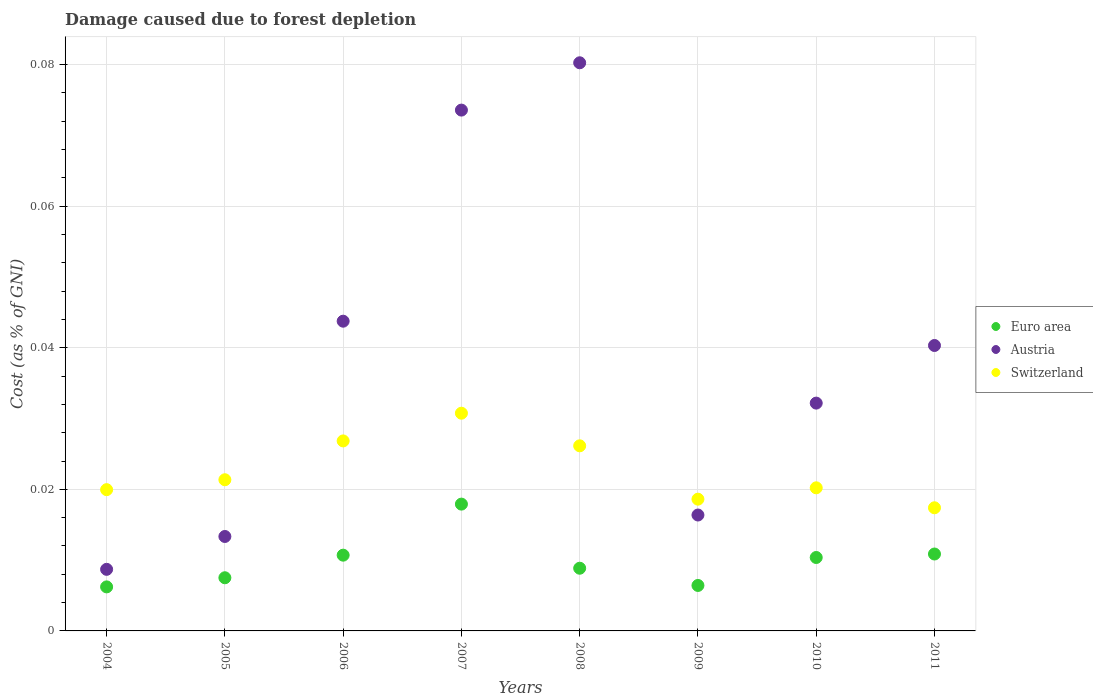Is the number of dotlines equal to the number of legend labels?
Provide a succinct answer. Yes. What is the cost of damage caused due to forest depletion in Austria in 2011?
Offer a terse response. 0.04. Across all years, what is the maximum cost of damage caused due to forest depletion in Austria?
Provide a succinct answer. 0.08. Across all years, what is the minimum cost of damage caused due to forest depletion in Austria?
Provide a short and direct response. 0.01. In which year was the cost of damage caused due to forest depletion in Switzerland minimum?
Give a very brief answer. 2011. What is the total cost of damage caused due to forest depletion in Euro area in the graph?
Your response must be concise. 0.08. What is the difference between the cost of damage caused due to forest depletion in Switzerland in 2006 and that in 2008?
Your answer should be compact. 0. What is the difference between the cost of damage caused due to forest depletion in Switzerland in 2009 and the cost of damage caused due to forest depletion in Austria in 2008?
Provide a short and direct response. -0.06. What is the average cost of damage caused due to forest depletion in Switzerland per year?
Provide a succinct answer. 0.02. In the year 2011, what is the difference between the cost of damage caused due to forest depletion in Switzerland and cost of damage caused due to forest depletion in Austria?
Give a very brief answer. -0.02. What is the ratio of the cost of damage caused due to forest depletion in Switzerland in 2009 to that in 2011?
Give a very brief answer. 1.07. Is the cost of damage caused due to forest depletion in Euro area in 2004 less than that in 2011?
Offer a terse response. Yes. Is the difference between the cost of damage caused due to forest depletion in Switzerland in 2005 and 2008 greater than the difference between the cost of damage caused due to forest depletion in Austria in 2005 and 2008?
Your response must be concise. Yes. What is the difference between the highest and the second highest cost of damage caused due to forest depletion in Switzerland?
Provide a short and direct response. 0. What is the difference between the highest and the lowest cost of damage caused due to forest depletion in Euro area?
Make the answer very short. 0.01. In how many years, is the cost of damage caused due to forest depletion in Euro area greater than the average cost of damage caused due to forest depletion in Euro area taken over all years?
Offer a very short reply. 4. Is the sum of the cost of damage caused due to forest depletion in Euro area in 2005 and 2009 greater than the maximum cost of damage caused due to forest depletion in Switzerland across all years?
Make the answer very short. No. Is it the case that in every year, the sum of the cost of damage caused due to forest depletion in Euro area and cost of damage caused due to forest depletion in Austria  is greater than the cost of damage caused due to forest depletion in Switzerland?
Give a very brief answer. No. Is the cost of damage caused due to forest depletion in Switzerland strictly greater than the cost of damage caused due to forest depletion in Austria over the years?
Make the answer very short. No. Is the cost of damage caused due to forest depletion in Switzerland strictly less than the cost of damage caused due to forest depletion in Austria over the years?
Make the answer very short. No. What is the difference between two consecutive major ticks on the Y-axis?
Provide a succinct answer. 0.02. Does the graph contain grids?
Make the answer very short. Yes. What is the title of the graph?
Your response must be concise. Damage caused due to forest depletion. Does "Peru" appear as one of the legend labels in the graph?
Offer a terse response. No. What is the label or title of the Y-axis?
Give a very brief answer. Cost (as % of GNI). What is the Cost (as % of GNI) in Euro area in 2004?
Offer a very short reply. 0.01. What is the Cost (as % of GNI) of Austria in 2004?
Provide a succinct answer. 0.01. What is the Cost (as % of GNI) of Switzerland in 2004?
Make the answer very short. 0.02. What is the Cost (as % of GNI) in Euro area in 2005?
Ensure brevity in your answer.  0.01. What is the Cost (as % of GNI) in Austria in 2005?
Offer a very short reply. 0.01. What is the Cost (as % of GNI) of Switzerland in 2005?
Provide a succinct answer. 0.02. What is the Cost (as % of GNI) in Euro area in 2006?
Offer a terse response. 0.01. What is the Cost (as % of GNI) of Austria in 2006?
Provide a short and direct response. 0.04. What is the Cost (as % of GNI) of Switzerland in 2006?
Offer a terse response. 0.03. What is the Cost (as % of GNI) of Euro area in 2007?
Ensure brevity in your answer.  0.02. What is the Cost (as % of GNI) of Austria in 2007?
Keep it short and to the point. 0.07. What is the Cost (as % of GNI) in Switzerland in 2007?
Offer a terse response. 0.03. What is the Cost (as % of GNI) of Euro area in 2008?
Provide a succinct answer. 0.01. What is the Cost (as % of GNI) of Austria in 2008?
Offer a very short reply. 0.08. What is the Cost (as % of GNI) of Switzerland in 2008?
Give a very brief answer. 0.03. What is the Cost (as % of GNI) in Euro area in 2009?
Provide a succinct answer. 0.01. What is the Cost (as % of GNI) in Austria in 2009?
Offer a terse response. 0.02. What is the Cost (as % of GNI) of Switzerland in 2009?
Make the answer very short. 0.02. What is the Cost (as % of GNI) of Euro area in 2010?
Make the answer very short. 0.01. What is the Cost (as % of GNI) in Austria in 2010?
Offer a terse response. 0.03. What is the Cost (as % of GNI) in Switzerland in 2010?
Make the answer very short. 0.02. What is the Cost (as % of GNI) of Euro area in 2011?
Make the answer very short. 0.01. What is the Cost (as % of GNI) of Austria in 2011?
Provide a succinct answer. 0.04. What is the Cost (as % of GNI) of Switzerland in 2011?
Ensure brevity in your answer.  0.02. Across all years, what is the maximum Cost (as % of GNI) of Euro area?
Keep it short and to the point. 0.02. Across all years, what is the maximum Cost (as % of GNI) in Austria?
Keep it short and to the point. 0.08. Across all years, what is the maximum Cost (as % of GNI) of Switzerland?
Offer a very short reply. 0.03. Across all years, what is the minimum Cost (as % of GNI) of Euro area?
Offer a terse response. 0.01. Across all years, what is the minimum Cost (as % of GNI) of Austria?
Give a very brief answer. 0.01. Across all years, what is the minimum Cost (as % of GNI) of Switzerland?
Make the answer very short. 0.02. What is the total Cost (as % of GNI) of Euro area in the graph?
Provide a succinct answer. 0.08. What is the total Cost (as % of GNI) of Austria in the graph?
Offer a terse response. 0.31. What is the total Cost (as % of GNI) of Switzerland in the graph?
Provide a short and direct response. 0.18. What is the difference between the Cost (as % of GNI) of Euro area in 2004 and that in 2005?
Give a very brief answer. -0. What is the difference between the Cost (as % of GNI) of Austria in 2004 and that in 2005?
Offer a terse response. -0. What is the difference between the Cost (as % of GNI) of Switzerland in 2004 and that in 2005?
Give a very brief answer. -0. What is the difference between the Cost (as % of GNI) of Euro area in 2004 and that in 2006?
Provide a short and direct response. -0. What is the difference between the Cost (as % of GNI) in Austria in 2004 and that in 2006?
Your response must be concise. -0.04. What is the difference between the Cost (as % of GNI) of Switzerland in 2004 and that in 2006?
Make the answer very short. -0.01. What is the difference between the Cost (as % of GNI) in Euro area in 2004 and that in 2007?
Offer a very short reply. -0.01. What is the difference between the Cost (as % of GNI) of Austria in 2004 and that in 2007?
Offer a very short reply. -0.06. What is the difference between the Cost (as % of GNI) of Switzerland in 2004 and that in 2007?
Give a very brief answer. -0.01. What is the difference between the Cost (as % of GNI) of Euro area in 2004 and that in 2008?
Provide a short and direct response. -0. What is the difference between the Cost (as % of GNI) in Austria in 2004 and that in 2008?
Keep it short and to the point. -0.07. What is the difference between the Cost (as % of GNI) of Switzerland in 2004 and that in 2008?
Offer a terse response. -0.01. What is the difference between the Cost (as % of GNI) of Euro area in 2004 and that in 2009?
Make the answer very short. -0. What is the difference between the Cost (as % of GNI) of Austria in 2004 and that in 2009?
Give a very brief answer. -0.01. What is the difference between the Cost (as % of GNI) in Switzerland in 2004 and that in 2009?
Ensure brevity in your answer.  0. What is the difference between the Cost (as % of GNI) of Euro area in 2004 and that in 2010?
Give a very brief answer. -0. What is the difference between the Cost (as % of GNI) of Austria in 2004 and that in 2010?
Provide a short and direct response. -0.02. What is the difference between the Cost (as % of GNI) in Switzerland in 2004 and that in 2010?
Offer a terse response. -0. What is the difference between the Cost (as % of GNI) in Euro area in 2004 and that in 2011?
Make the answer very short. -0. What is the difference between the Cost (as % of GNI) of Austria in 2004 and that in 2011?
Your response must be concise. -0.03. What is the difference between the Cost (as % of GNI) of Switzerland in 2004 and that in 2011?
Give a very brief answer. 0. What is the difference between the Cost (as % of GNI) in Euro area in 2005 and that in 2006?
Offer a terse response. -0. What is the difference between the Cost (as % of GNI) of Austria in 2005 and that in 2006?
Offer a very short reply. -0.03. What is the difference between the Cost (as % of GNI) in Switzerland in 2005 and that in 2006?
Provide a succinct answer. -0.01. What is the difference between the Cost (as % of GNI) of Euro area in 2005 and that in 2007?
Offer a terse response. -0.01. What is the difference between the Cost (as % of GNI) in Austria in 2005 and that in 2007?
Offer a very short reply. -0.06. What is the difference between the Cost (as % of GNI) of Switzerland in 2005 and that in 2007?
Offer a very short reply. -0.01. What is the difference between the Cost (as % of GNI) of Euro area in 2005 and that in 2008?
Your response must be concise. -0. What is the difference between the Cost (as % of GNI) of Austria in 2005 and that in 2008?
Your answer should be very brief. -0.07. What is the difference between the Cost (as % of GNI) in Switzerland in 2005 and that in 2008?
Ensure brevity in your answer.  -0. What is the difference between the Cost (as % of GNI) of Euro area in 2005 and that in 2009?
Offer a terse response. 0. What is the difference between the Cost (as % of GNI) in Austria in 2005 and that in 2009?
Keep it short and to the point. -0. What is the difference between the Cost (as % of GNI) of Switzerland in 2005 and that in 2009?
Make the answer very short. 0. What is the difference between the Cost (as % of GNI) of Euro area in 2005 and that in 2010?
Give a very brief answer. -0. What is the difference between the Cost (as % of GNI) of Austria in 2005 and that in 2010?
Make the answer very short. -0.02. What is the difference between the Cost (as % of GNI) of Switzerland in 2005 and that in 2010?
Your answer should be compact. 0. What is the difference between the Cost (as % of GNI) of Euro area in 2005 and that in 2011?
Provide a short and direct response. -0. What is the difference between the Cost (as % of GNI) of Austria in 2005 and that in 2011?
Your answer should be very brief. -0.03. What is the difference between the Cost (as % of GNI) of Switzerland in 2005 and that in 2011?
Offer a very short reply. 0. What is the difference between the Cost (as % of GNI) in Euro area in 2006 and that in 2007?
Offer a terse response. -0.01. What is the difference between the Cost (as % of GNI) in Austria in 2006 and that in 2007?
Your response must be concise. -0.03. What is the difference between the Cost (as % of GNI) of Switzerland in 2006 and that in 2007?
Your answer should be very brief. -0. What is the difference between the Cost (as % of GNI) of Euro area in 2006 and that in 2008?
Provide a short and direct response. 0. What is the difference between the Cost (as % of GNI) in Austria in 2006 and that in 2008?
Give a very brief answer. -0.04. What is the difference between the Cost (as % of GNI) of Switzerland in 2006 and that in 2008?
Offer a terse response. 0. What is the difference between the Cost (as % of GNI) of Euro area in 2006 and that in 2009?
Keep it short and to the point. 0. What is the difference between the Cost (as % of GNI) in Austria in 2006 and that in 2009?
Your response must be concise. 0.03. What is the difference between the Cost (as % of GNI) of Switzerland in 2006 and that in 2009?
Keep it short and to the point. 0.01. What is the difference between the Cost (as % of GNI) in Austria in 2006 and that in 2010?
Provide a short and direct response. 0.01. What is the difference between the Cost (as % of GNI) of Switzerland in 2006 and that in 2010?
Your response must be concise. 0.01. What is the difference between the Cost (as % of GNI) in Euro area in 2006 and that in 2011?
Give a very brief answer. -0. What is the difference between the Cost (as % of GNI) of Austria in 2006 and that in 2011?
Your answer should be very brief. 0. What is the difference between the Cost (as % of GNI) in Switzerland in 2006 and that in 2011?
Provide a succinct answer. 0.01. What is the difference between the Cost (as % of GNI) in Euro area in 2007 and that in 2008?
Give a very brief answer. 0.01. What is the difference between the Cost (as % of GNI) of Austria in 2007 and that in 2008?
Your response must be concise. -0.01. What is the difference between the Cost (as % of GNI) of Switzerland in 2007 and that in 2008?
Offer a very short reply. 0. What is the difference between the Cost (as % of GNI) of Euro area in 2007 and that in 2009?
Keep it short and to the point. 0.01. What is the difference between the Cost (as % of GNI) in Austria in 2007 and that in 2009?
Make the answer very short. 0.06. What is the difference between the Cost (as % of GNI) in Switzerland in 2007 and that in 2009?
Make the answer very short. 0.01. What is the difference between the Cost (as % of GNI) in Euro area in 2007 and that in 2010?
Give a very brief answer. 0.01. What is the difference between the Cost (as % of GNI) in Austria in 2007 and that in 2010?
Your response must be concise. 0.04. What is the difference between the Cost (as % of GNI) in Switzerland in 2007 and that in 2010?
Your response must be concise. 0.01. What is the difference between the Cost (as % of GNI) of Euro area in 2007 and that in 2011?
Your answer should be very brief. 0.01. What is the difference between the Cost (as % of GNI) of Switzerland in 2007 and that in 2011?
Provide a succinct answer. 0.01. What is the difference between the Cost (as % of GNI) in Euro area in 2008 and that in 2009?
Your answer should be very brief. 0. What is the difference between the Cost (as % of GNI) in Austria in 2008 and that in 2009?
Ensure brevity in your answer.  0.06. What is the difference between the Cost (as % of GNI) of Switzerland in 2008 and that in 2009?
Provide a succinct answer. 0.01. What is the difference between the Cost (as % of GNI) in Euro area in 2008 and that in 2010?
Your response must be concise. -0. What is the difference between the Cost (as % of GNI) in Austria in 2008 and that in 2010?
Your answer should be very brief. 0.05. What is the difference between the Cost (as % of GNI) of Switzerland in 2008 and that in 2010?
Ensure brevity in your answer.  0.01. What is the difference between the Cost (as % of GNI) of Euro area in 2008 and that in 2011?
Provide a short and direct response. -0. What is the difference between the Cost (as % of GNI) in Austria in 2008 and that in 2011?
Offer a terse response. 0.04. What is the difference between the Cost (as % of GNI) of Switzerland in 2008 and that in 2011?
Provide a succinct answer. 0.01. What is the difference between the Cost (as % of GNI) of Euro area in 2009 and that in 2010?
Offer a very short reply. -0. What is the difference between the Cost (as % of GNI) in Austria in 2009 and that in 2010?
Provide a succinct answer. -0.02. What is the difference between the Cost (as % of GNI) of Switzerland in 2009 and that in 2010?
Your answer should be very brief. -0. What is the difference between the Cost (as % of GNI) in Euro area in 2009 and that in 2011?
Make the answer very short. -0. What is the difference between the Cost (as % of GNI) of Austria in 2009 and that in 2011?
Make the answer very short. -0.02. What is the difference between the Cost (as % of GNI) in Switzerland in 2009 and that in 2011?
Your answer should be very brief. 0. What is the difference between the Cost (as % of GNI) in Euro area in 2010 and that in 2011?
Offer a terse response. -0. What is the difference between the Cost (as % of GNI) of Austria in 2010 and that in 2011?
Make the answer very short. -0.01. What is the difference between the Cost (as % of GNI) of Switzerland in 2010 and that in 2011?
Keep it short and to the point. 0. What is the difference between the Cost (as % of GNI) in Euro area in 2004 and the Cost (as % of GNI) in Austria in 2005?
Make the answer very short. -0.01. What is the difference between the Cost (as % of GNI) of Euro area in 2004 and the Cost (as % of GNI) of Switzerland in 2005?
Make the answer very short. -0.02. What is the difference between the Cost (as % of GNI) in Austria in 2004 and the Cost (as % of GNI) in Switzerland in 2005?
Make the answer very short. -0.01. What is the difference between the Cost (as % of GNI) of Euro area in 2004 and the Cost (as % of GNI) of Austria in 2006?
Offer a very short reply. -0.04. What is the difference between the Cost (as % of GNI) of Euro area in 2004 and the Cost (as % of GNI) of Switzerland in 2006?
Offer a terse response. -0.02. What is the difference between the Cost (as % of GNI) in Austria in 2004 and the Cost (as % of GNI) in Switzerland in 2006?
Give a very brief answer. -0.02. What is the difference between the Cost (as % of GNI) of Euro area in 2004 and the Cost (as % of GNI) of Austria in 2007?
Provide a short and direct response. -0.07. What is the difference between the Cost (as % of GNI) in Euro area in 2004 and the Cost (as % of GNI) in Switzerland in 2007?
Ensure brevity in your answer.  -0.02. What is the difference between the Cost (as % of GNI) in Austria in 2004 and the Cost (as % of GNI) in Switzerland in 2007?
Offer a very short reply. -0.02. What is the difference between the Cost (as % of GNI) of Euro area in 2004 and the Cost (as % of GNI) of Austria in 2008?
Your answer should be very brief. -0.07. What is the difference between the Cost (as % of GNI) in Euro area in 2004 and the Cost (as % of GNI) in Switzerland in 2008?
Offer a very short reply. -0.02. What is the difference between the Cost (as % of GNI) in Austria in 2004 and the Cost (as % of GNI) in Switzerland in 2008?
Your answer should be compact. -0.02. What is the difference between the Cost (as % of GNI) in Euro area in 2004 and the Cost (as % of GNI) in Austria in 2009?
Offer a terse response. -0.01. What is the difference between the Cost (as % of GNI) of Euro area in 2004 and the Cost (as % of GNI) of Switzerland in 2009?
Offer a terse response. -0.01. What is the difference between the Cost (as % of GNI) of Austria in 2004 and the Cost (as % of GNI) of Switzerland in 2009?
Offer a very short reply. -0.01. What is the difference between the Cost (as % of GNI) in Euro area in 2004 and the Cost (as % of GNI) in Austria in 2010?
Your response must be concise. -0.03. What is the difference between the Cost (as % of GNI) of Euro area in 2004 and the Cost (as % of GNI) of Switzerland in 2010?
Offer a very short reply. -0.01. What is the difference between the Cost (as % of GNI) of Austria in 2004 and the Cost (as % of GNI) of Switzerland in 2010?
Provide a short and direct response. -0.01. What is the difference between the Cost (as % of GNI) of Euro area in 2004 and the Cost (as % of GNI) of Austria in 2011?
Keep it short and to the point. -0.03. What is the difference between the Cost (as % of GNI) of Euro area in 2004 and the Cost (as % of GNI) of Switzerland in 2011?
Your response must be concise. -0.01. What is the difference between the Cost (as % of GNI) of Austria in 2004 and the Cost (as % of GNI) of Switzerland in 2011?
Your answer should be compact. -0.01. What is the difference between the Cost (as % of GNI) in Euro area in 2005 and the Cost (as % of GNI) in Austria in 2006?
Your response must be concise. -0.04. What is the difference between the Cost (as % of GNI) in Euro area in 2005 and the Cost (as % of GNI) in Switzerland in 2006?
Your answer should be compact. -0.02. What is the difference between the Cost (as % of GNI) in Austria in 2005 and the Cost (as % of GNI) in Switzerland in 2006?
Your answer should be very brief. -0.01. What is the difference between the Cost (as % of GNI) in Euro area in 2005 and the Cost (as % of GNI) in Austria in 2007?
Your answer should be very brief. -0.07. What is the difference between the Cost (as % of GNI) in Euro area in 2005 and the Cost (as % of GNI) in Switzerland in 2007?
Offer a terse response. -0.02. What is the difference between the Cost (as % of GNI) of Austria in 2005 and the Cost (as % of GNI) of Switzerland in 2007?
Make the answer very short. -0.02. What is the difference between the Cost (as % of GNI) of Euro area in 2005 and the Cost (as % of GNI) of Austria in 2008?
Offer a terse response. -0.07. What is the difference between the Cost (as % of GNI) in Euro area in 2005 and the Cost (as % of GNI) in Switzerland in 2008?
Ensure brevity in your answer.  -0.02. What is the difference between the Cost (as % of GNI) of Austria in 2005 and the Cost (as % of GNI) of Switzerland in 2008?
Provide a succinct answer. -0.01. What is the difference between the Cost (as % of GNI) in Euro area in 2005 and the Cost (as % of GNI) in Austria in 2009?
Provide a short and direct response. -0.01. What is the difference between the Cost (as % of GNI) in Euro area in 2005 and the Cost (as % of GNI) in Switzerland in 2009?
Give a very brief answer. -0.01. What is the difference between the Cost (as % of GNI) in Austria in 2005 and the Cost (as % of GNI) in Switzerland in 2009?
Offer a terse response. -0.01. What is the difference between the Cost (as % of GNI) of Euro area in 2005 and the Cost (as % of GNI) of Austria in 2010?
Give a very brief answer. -0.02. What is the difference between the Cost (as % of GNI) of Euro area in 2005 and the Cost (as % of GNI) of Switzerland in 2010?
Your answer should be compact. -0.01. What is the difference between the Cost (as % of GNI) in Austria in 2005 and the Cost (as % of GNI) in Switzerland in 2010?
Your response must be concise. -0.01. What is the difference between the Cost (as % of GNI) of Euro area in 2005 and the Cost (as % of GNI) of Austria in 2011?
Your answer should be compact. -0.03. What is the difference between the Cost (as % of GNI) of Euro area in 2005 and the Cost (as % of GNI) of Switzerland in 2011?
Provide a short and direct response. -0.01. What is the difference between the Cost (as % of GNI) in Austria in 2005 and the Cost (as % of GNI) in Switzerland in 2011?
Make the answer very short. -0. What is the difference between the Cost (as % of GNI) in Euro area in 2006 and the Cost (as % of GNI) in Austria in 2007?
Your answer should be compact. -0.06. What is the difference between the Cost (as % of GNI) of Euro area in 2006 and the Cost (as % of GNI) of Switzerland in 2007?
Ensure brevity in your answer.  -0.02. What is the difference between the Cost (as % of GNI) of Austria in 2006 and the Cost (as % of GNI) of Switzerland in 2007?
Your answer should be compact. 0.01. What is the difference between the Cost (as % of GNI) in Euro area in 2006 and the Cost (as % of GNI) in Austria in 2008?
Give a very brief answer. -0.07. What is the difference between the Cost (as % of GNI) in Euro area in 2006 and the Cost (as % of GNI) in Switzerland in 2008?
Offer a terse response. -0.02. What is the difference between the Cost (as % of GNI) in Austria in 2006 and the Cost (as % of GNI) in Switzerland in 2008?
Give a very brief answer. 0.02. What is the difference between the Cost (as % of GNI) in Euro area in 2006 and the Cost (as % of GNI) in Austria in 2009?
Keep it short and to the point. -0.01. What is the difference between the Cost (as % of GNI) of Euro area in 2006 and the Cost (as % of GNI) of Switzerland in 2009?
Your answer should be compact. -0.01. What is the difference between the Cost (as % of GNI) in Austria in 2006 and the Cost (as % of GNI) in Switzerland in 2009?
Provide a short and direct response. 0.03. What is the difference between the Cost (as % of GNI) of Euro area in 2006 and the Cost (as % of GNI) of Austria in 2010?
Offer a very short reply. -0.02. What is the difference between the Cost (as % of GNI) in Euro area in 2006 and the Cost (as % of GNI) in Switzerland in 2010?
Provide a short and direct response. -0.01. What is the difference between the Cost (as % of GNI) of Austria in 2006 and the Cost (as % of GNI) of Switzerland in 2010?
Your answer should be very brief. 0.02. What is the difference between the Cost (as % of GNI) of Euro area in 2006 and the Cost (as % of GNI) of Austria in 2011?
Offer a terse response. -0.03. What is the difference between the Cost (as % of GNI) of Euro area in 2006 and the Cost (as % of GNI) of Switzerland in 2011?
Give a very brief answer. -0.01. What is the difference between the Cost (as % of GNI) in Austria in 2006 and the Cost (as % of GNI) in Switzerland in 2011?
Offer a very short reply. 0.03. What is the difference between the Cost (as % of GNI) of Euro area in 2007 and the Cost (as % of GNI) of Austria in 2008?
Your answer should be very brief. -0.06. What is the difference between the Cost (as % of GNI) of Euro area in 2007 and the Cost (as % of GNI) of Switzerland in 2008?
Offer a terse response. -0.01. What is the difference between the Cost (as % of GNI) in Austria in 2007 and the Cost (as % of GNI) in Switzerland in 2008?
Make the answer very short. 0.05. What is the difference between the Cost (as % of GNI) of Euro area in 2007 and the Cost (as % of GNI) of Austria in 2009?
Offer a terse response. 0. What is the difference between the Cost (as % of GNI) of Euro area in 2007 and the Cost (as % of GNI) of Switzerland in 2009?
Your answer should be very brief. -0. What is the difference between the Cost (as % of GNI) in Austria in 2007 and the Cost (as % of GNI) in Switzerland in 2009?
Offer a terse response. 0.06. What is the difference between the Cost (as % of GNI) of Euro area in 2007 and the Cost (as % of GNI) of Austria in 2010?
Make the answer very short. -0.01. What is the difference between the Cost (as % of GNI) of Euro area in 2007 and the Cost (as % of GNI) of Switzerland in 2010?
Your answer should be very brief. -0. What is the difference between the Cost (as % of GNI) of Austria in 2007 and the Cost (as % of GNI) of Switzerland in 2010?
Provide a short and direct response. 0.05. What is the difference between the Cost (as % of GNI) of Euro area in 2007 and the Cost (as % of GNI) of Austria in 2011?
Ensure brevity in your answer.  -0.02. What is the difference between the Cost (as % of GNI) of Euro area in 2007 and the Cost (as % of GNI) of Switzerland in 2011?
Offer a terse response. 0. What is the difference between the Cost (as % of GNI) of Austria in 2007 and the Cost (as % of GNI) of Switzerland in 2011?
Make the answer very short. 0.06. What is the difference between the Cost (as % of GNI) in Euro area in 2008 and the Cost (as % of GNI) in Austria in 2009?
Offer a very short reply. -0.01. What is the difference between the Cost (as % of GNI) of Euro area in 2008 and the Cost (as % of GNI) of Switzerland in 2009?
Make the answer very short. -0.01. What is the difference between the Cost (as % of GNI) in Austria in 2008 and the Cost (as % of GNI) in Switzerland in 2009?
Your answer should be compact. 0.06. What is the difference between the Cost (as % of GNI) of Euro area in 2008 and the Cost (as % of GNI) of Austria in 2010?
Your answer should be very brief. -0.02. What is the difference between the Cost (as % of GNI) of Euro area in 2008 and the Cost (as % of GNI) of Switzerland in 2010?
Make the answer very short. -0.01. What is the difference between the Cost (as % of GNI) of Austria in 2008 and the Cost (as % of GNI) of Switzerland in 2010?
Offer a very short reply. 0.06. What is the difference between the Cost (as % of GNI) of Euro area in 2008 and the Cost (as % of GNI) of Austria in 2011?
Provide a short and direct response. -0.03. What is the difference between the Cost (as % of GNI) of Euro area in 2008 and the Cost (as % of GNI) of Switzerland in 2011?
Provide a succinct answer. -0.01. What is the difference between the Cost (as % of GNI) in Austria in 2008 and the Cost (as % of GNI) in Switzerland in 2011?
Ensure brevity in your answer.  0.06. What is the difference between the Cost (as % of GNI) in Euro area in 2009 and the Cost (as % of GNI) in Austria in 2010?
Give a very brief answer. -0.03. What is the difference between the Cost (as % of GNI) of Euro area in 2009 and the Cost (as % of GNI) of Switzerland in 2010?
Your answer should be very brief. -0.01. What is the difference between the Cost (as % of GNI) of Austria in 2009 and the Cost (as % of GNI) of Switzerland in 2010?
Offer a very short reply. -0. What is the difference between the Cost (as % of GNI) of Euro area in 2009 and the Cost (as % of GNI) of Austria in 2011?
Make the answer very short. -0.03. What is the difference between the Cost (as % of GNI) in Euro area in 2009 and the Cost (as % of GNI) in Switzerland in 2011?
Provide a succinct answer. -0.01. What is the difference between the Cost (as % of GNI) in Austria in 2009 and the Cost (as % of GNI) in Switzerland in 2011?
Make the answer very short. -0. What is the difference between the Cost (as % of GNI) in Euro area in 2010 and the Cost (as % of GNI) in Austria in 2011?
Provide a short and direct response. -0.03. What is the difference between the Cost (as % of GNI) in Euro area in 2010 and the Cost (as % of GNI) in Switzerland in 2011?
Ensure brevity in your answer.  -0.01. What is the difference between the Cost (as % of GNI) in Austria in 2010 and the Cost (as % of GNI) in Switzerland in 2011?
Offer a terse response. 0.01. What is the average Cost (as % of GNI) in Euro area per year?
Your answer should be compact. 0.01. What is the average Cost (as % of GNI) of Austria per year?
Give a very brief answer. 0.04. What is the average Cost (as % of GNI) of Switzerland per year?
Your response must be concise. 0.02. In the year 2004, what is the difference between the Cost (as % of GNI) in Euro area and Cost (as % of GNI) in Austria?
Give a very brief answer. -0. In the year 2004, what is the difference between the Cost (as % of GNI) in Euro area and Cost (as % of GNI) in Switzerland?
Your response must be concise. -0.01. In the year 2004, what is the difference between the Cost (as % of GNI) of Austria and Cost (as % of GNI) of Switzerland?
Offer a terse response. -0.01. In the year 2005, what is the difference between the Cost (as % of GNI) of Euro area and Cost (as % of GNI) of Austria?
Give a very brief answer. -0.01. In the year 2005, what is the difference between the Cost (as % of GNI) of Euro area and Cost (as % of GNI) of Switzerland?
Your answer should be compact. -0.01. In the year 2005, what is the difference between the Cost (as % of GNI) in Austria and Cost (as % of GNI) in Switzerland?
Offer a very short reply. -0.01. In the year 2006, what is the difference between the Cost (as % of GNI) in Euro area and Cost (as % of GNI) in Austria?
Offer a terse response. -0.03. In the year 2006, what is the difference between the Cost (as % of GNI) of Euro area and Cost (as % of GNI) of Switzerland?
Make the answer very short. -0.02. In the year 2006, what is the difference between the Cost (as % of GNI) in Austria and Cost (as % of GNI) in Switzerland?
Your answer should be compact. 0.02. In the year 2007, what is the difference between the Cost (as % of GNI) in Euro area and Cost (as % of GNI) in Austria?
Make the answer very short. -0.06. In the year 2007, what is the difference between the Cost (as % of GNI) of Euro area and Cost (as % of GNI) of Switzerland?
Offer a terse response. -0.01. In the year 2007, what is the difference between the Cost (as % of GNI) in Austria and Cost (as % of GNI) in Switzerland?
Your response must be concise. 0.04. In the year 2008, what is the difference between the Cost (as % of GNI) of Euro area and Cost (as % of GNI) of Austria?
Your answer should be very brief. -0.07. In the year 2008, what is the difference between the Cost (as % of GNI) in Euro area and Cost (as % of GNI) in Switzerland?
Your response must be concise. -0.02. In the year 2008, what is the difference between the Cost (as % of GNI) of Austria and Cost (as % of GNI) of Switzerland?
Your answer should be very brief. 0.05. In the year 2009, what is the difference between the Cost (as % of GNI) in Euro area and Cost (as % of GNI) in Austria?
Make the answer very short. -0.01. In the year 2009, what is the difference between the Cost (as % of GNI) of Euro area and Cost (as % of GNI) of Switzerland?
Keep it short and to the point. -0.01. In the year 2009, what is the difference between the Cost (as % of GNI) of Austria and Cost (as % of GNI) of Switzerland?
Give a very brief answer. -0. In the year 2010, what is the difference between the Cost (as % of GNI) in Euro area and Cost (as % of GNI) in Austria?
Offer a terse response. -0.02. In the year 2010, what is the difference between the Cost (as % of GNI) in Euro area and Cost (as % of GNI) in Switzerland?
Offer a very short reply. -0.01. In the year 2010, what is the difference between the Cost (as % of GNI) of Austria and Cost (as % of GNI) of Switzerland?
Your answer should be very brief. 0.01. In the year 2011, what is the difference between the Cost (as % of GNI) of Euro area and Cost (as % of GNI) of Austria?
Give a very brief answer. -0.03. In the year 2011, what is the difference between the Cost (as % of GNI) in Euro area and Cost (as % of GNI) in Switzerland?
Your response must be concise. -0.01. In the year 2011, what is the difference between the Cost (as % of GNI) of Austria and Cost (as % of GNI) of Switzerland?
Offer a very short reply. 0.02. What is the ratio of the Cost (as % of GNI) of Euro area in 2004 to that in 2005?
Provide a short and direct response. 0.83. What is the ratio of the Cost (as % of GNI) of Austria in 2004 to that in 2005?
Offer a very short reply. 0.65. What is the ratio of the Cost (as % of GNI) in Switzerland in 2004 to that in 2005?
Ensure brevity in your answer.  0.93. What is the ratio of the Cost (as % of GNI) in Euro area in 2004 to that in 2006?
Offer a very short reply. 0.58. What is the ratio of the Cost (as % of GNI) in Austria in 2004 to that in 2006?
Give a very brief answer. 0.2. What is the ratio of the Cost (as % of GNI) in Switzerland in 2004 to that in 2006?
Your answer should be compact. 0.74. What is the ratio of the Cost (as % of GNI) in Euro area in 2004 to that in 2007?
Provide a succinct answer. 0.35. What is the ratio of the Cost (as % of GNI) of Austria in 2004 to that in 2007?
Your answer should be very brief. 0.12. What is the ratio of the Cost (as % of GNI) in Switzerland in 2004 to that in 2007?
Your answer should be very brief. 0.65. What is the ratio of the Cost (as % of GNI) in Euro area in 2004 to that in 2008?
Your response must be concise. 0.7. What is the ratio of the Cost (as % of GNI) of Austria in 2004 to that in 2008?
Give a very brief answer. 0.11. What is the ratio of the Cost (as % of GNI) in Switzerland in 2004 to that in 2008?
Offer a very short reply. 0.76. What is the ratio of the Cost (as % of GNI) in Euro area in 2004 to that in 2009?
Provide a succinct answer. 0.97. What is the ratio of the Cost (as % of GNI) of Austria in 2004 to that in 2009?
Offer a terse response. 0.53. What is the ratio of the Cost (as % of GNI) of Switzerland in 2004 to that in 2009?
Your answer should be compact. 1.07. What is the ratio of the Cost (as % of GNI) of Euro area in 2004 to that in 2010?
Your answer should be compact. 0.6. What is the ratio of the Cost (as % of GNI) in Austria in 2004 to that in 2010?
Your answer should be very brief. 0.27. What is the ratio of the Cost (as % of GNI) of Switzerland in 2004 to that in 2010?
Provide a succinct answer. 0.99. What is the ratio of the Cost (as % of GNI) of Euro area in 2004 to that in 2011?
Give a very brief answer. 0.57. What is the ratio of the Cost (as % of GNI) in Austria in 2004 to that in 2011?
Your answer should be very brief. 0.22. What is the ratio of the Cost (as % of GNI) of Switzerland in 2004 to that in 2011?
Provide a succinct answer. 1.15. What is the ratio of the Cost (as % of GNI) in Euro area in 2005 to that in 2006?
Your response must be concise. 0.7. What is the ratio of the Cost (as % of GNI) in Austria in 2005 to that in 2006?
Make the answer very short. 0.3. What is the ratio of the Cost (as % of GNI) in Switzerland in 2005 to that in 2006?
Provide a short and direct response. 0.8. What is the ratio of the Cost (as % of GNI) in Euro area in 2005 to that in 2007?
Your answer should be very brief. 0.42. What is the ratio of the Cost (as % of GNI) in Austria in 2005 to that in 2007?
Give a very brief answer. 0.18. What is the ratio of the Cost (as % of GNI) of Switzerland in 2005 to that in 2007?
Make the answer very short. 0.69. What is the ratio of the Cost (as % of GNI) of Euro area in 2005 to that in 2008?
Provide a succinct answer. 0.85. What is the ratio of the Cost (as % of GNI) in Austria in 2005 to that in 2008?
Offer a very short reply. 0.17. What is the ratio of the Cost (as % of GNI) in Switzerland in 2005 to that in 2008?
Give a very brief answer. 0.82. What is the ratio of the Cost (as % of GNI) of Euro area in 2005 to that in 2009?
Ensure brevity in your answer.  1.17. What is the ratio of the Cost (as % of GNI) in Austria in 2005 to that in 2009?
Your answer should be very brief. 0.81. What is the ratio of the Cost (as % of GNI) in Switzerland in 2005 to that in 2009?
Provide a short and direct response. 1.15. What is the ratio of the Cost (as % of GNI) in Euro area in 2005 to that in 2010?
Ensure brevity in your answer.  0.72. What is the ratio of the Cost (as % of GNI) in Austria in 2005 to that in 2010?
Offer a terse response. 0.41. What is the ratio of the Cost (as % of GNI) of Switzerland in 2005 to that in 2010?
Give a very brief answer. 1.06. What is the ratio of the Cost (as % of GNI) in Euro area in 2005 to that in 2011?
Give a very brief answer. 0.69. What is the ratio of the Cost (as % of GNI) in Austria in 2005 to that in 2011?
Provide a short and direct response. 0.33. What is the ratio of the Cost (as % of GNI) of Switzerland in 2005 to that in 2011?
Provide a short and direct response. 1.23. What is the ratio of the Cost (as % of GNI) in Euro area in 2006 to that in 2007?
Your answer should be very brief. 0.6. What is the ratio of the Cost (as % of GNI) in Austria in 2006 to that in 2007?
Provide a short and direct response. 0.59. What is the ratio of the Cost (as % of GNI) in Switzerland in 2006 to that in 2007?
Provide a succinct answer. 0.87. What is the ratio of the Cost (as % of GNI) in Euro area in 2006 to that in 2008?
Ensure brevity in your answer.  1.21. What is the ratio of the Cost (as % of GNI) in Austria in 2006 to that in 2008?
Your answer should be compact. 0.55. What is the ratio of the Cost (as % of GNI) of Switzerland in 2006 to that in 2008?
Your answer should be compact. 1.03. What is the ratio of the Cost (as % of GNI) of Euro area in 2006 to that in 2009?
Offer a terse response. 1.67. What is the ratio of the Cost (as % of GNI) in Austria in 2006 to that in 2009?
Your answer should be compact. 2.67. What is the ratio of the Cost (as % of GNI) of Switzerland in 2006 to that in 2009?
Offer a very short reply. 1.44. What is the ratio of the Cost (as % of GNI) of Euro area in 2006 to that in 2010?
Provide a succinct answer. 1.03. What is the ratio of the Cost (as % of GNI) in Austria in 2006 to that in 2010?
Make the answer very short. 1.36. What is the ratio of the Cost (as % of GNI) in Switzerland in 2006 to that in 2010?
Ensure brevity in your answer.  1.33. What is the ratio of the Cost (as % of GNI) of Austria in 2006 to that in 2011?
Give a very brief answer. 1.09. What is the ratio of the Cost (as % of GNI) of Switzerland in 2006 to that in 2011?
Ensure brevity in your answer.  1.54. What is the ratio of the Cost (as % of GNI) of Euro area in 2007 to that in 2008?
Provide a succinct answer. 2.02. What is the ratio of the Cost (as % of GNI) of Switzerland in 2007 to that in 2008?
Make the answer very short. 1.18. What is the ratio of the Cost (as % of GNI) in Euro area in 2007 to that in 2009?
Your answer should be compact. 2.79. What is the ratio of the Cost (as % of GNI) of Austria in 2007 to that in 2009?
Your answer should be compact. 4.49. What is the ratio of the Cost (as % of GNI) of Switzerland in 2007 to that in 2009?
Keep it short and to the point. 1.65. What is the ratio of the Cost (as % of GNI) in Euro area in 2007 to that in 2010?
Your answer should be compact. 1.73. What is the ratio of the Cost (as % of GNI) of Austria in 2007 to that in 2010?
Provide a succinct answer. 2.29. What is the ratio of the Cost (as % of GNI) of Switzerland in 2007 to that in 2010?
Offer a very short reply. 1.52. What is the ratio of the Cost (as % of GNI) in Euro area in 2007 to that in 2011?
Make the answer very short. 1.65. What is the ratio of the Cost (as % of GNI) of Austria in 2007 to that in 2011?
Your answer should be very brief. 1.82. What is the ratio of the Cost (as % of GNI) of Switzerland in 2007 to that in 2011?
Make the answer very short. 1.77. What is the ratio of the Cost (as % of GNI) in Euro area in 2008 to that in 2009?
Offer a very short reply. 1.38. What is the ratio of the Cost (as % of GNI) in Austria in 2008 to that in 2009?
Give a very brief answer. 4.9. What is the ratio of the Cost (as % of GNI) in Switzerland in 2008 to that in 2009?
Provide a succinct answer. 1.41. What is the ratio of the Cost (as % of GNI) of Euro area in 2008 to that in 2010?
Offer a terse response. 0.85. What is the ratio of the Cost (as % of GNI) in Austria in 2008 to that in 2010?
Offer a terse response. 2.49. What is the ratio of the Cost (as % of GNI) in Switzerland in 2008 to that in 2010?
Provide a succinct answer. 1.29. What is the ratio of the Cost (as % of GNI) of Euro area in 2008 to that in 2011?
Your response must be concise. 0.82. What is the ratio of the Cost (as % of GNI) in Austria in 2008 to that in 2011?
Provide a short and direct response. 1.99. What is the ratio of the Cost (as % of GNI) of Switzerland in 2008 to that in 2011?
Your answer should be very brief. 1.5. What is the ratio of the Cost (as % of GNI) of Euro area in 2009 to that in 2010?
Ensure brevity in your answer.  0.62. What is the ratio of the Cost (as % of GNI) in Austria in 2009 to that in 2010?
Provide a short and direct response. 0.51. What is the ratio of the Cost (as % of GNI) in Switzerland in 2009 to that in 2010?
Make the answer very short. 0.92. What is the ratio of the Cost (as % of GNI) of Euro area in 2009 to that in 2011?
Provide a short and direct response. 0.59. What is the ratio of the Cost (as % of GNI) of Austria in 2009 to that in 2011?
Your answer should be very brief. 0.41. What is the ratio of the Cost (as % of GNI) in Switzerland in 2009 to that in 2011?
Keep it short and to the point. 1.07. What is the ratio of the Cost (as % of GNI) of Euro area in 2010 to that in 2011?
Provide a succinct answer. 0.95. What is the ratio of the Cost (as % of GNI) of Austria in 2010 to that in 2011?
Keep it short and to the point. 0.8. What is the ratio of the Cost (as % of GNI) in Switzerland in 2010 to that in 2011?
Provide a succinct answer. 1.16. What is the difference between the highest and the second highest Cost (as % of GNI) of Euro area?
Provide a succinct answer. 0.01. What is the difference between the highest and the second highest Cost (as % of GNI) of Austria?
Ensure brevity in your answer.  0.01. What is the difference between the highest and the second highest Cost (as % of GNI) in Switzerland?
Provide a short and direct response. 0. What is the difference between the highest and the lowest Cost (as % of GNI) in Euro area?
Make the answer very short. 0.01. What is the difference between the highest and the lowest Cost (as % of GNI) of Austria?
Your answer should be very brief. 0.07. What is the difference between the highest and the lowest Cost (as % of GNI) of Switzerland?
Your answer should be very brief. 0.01. 